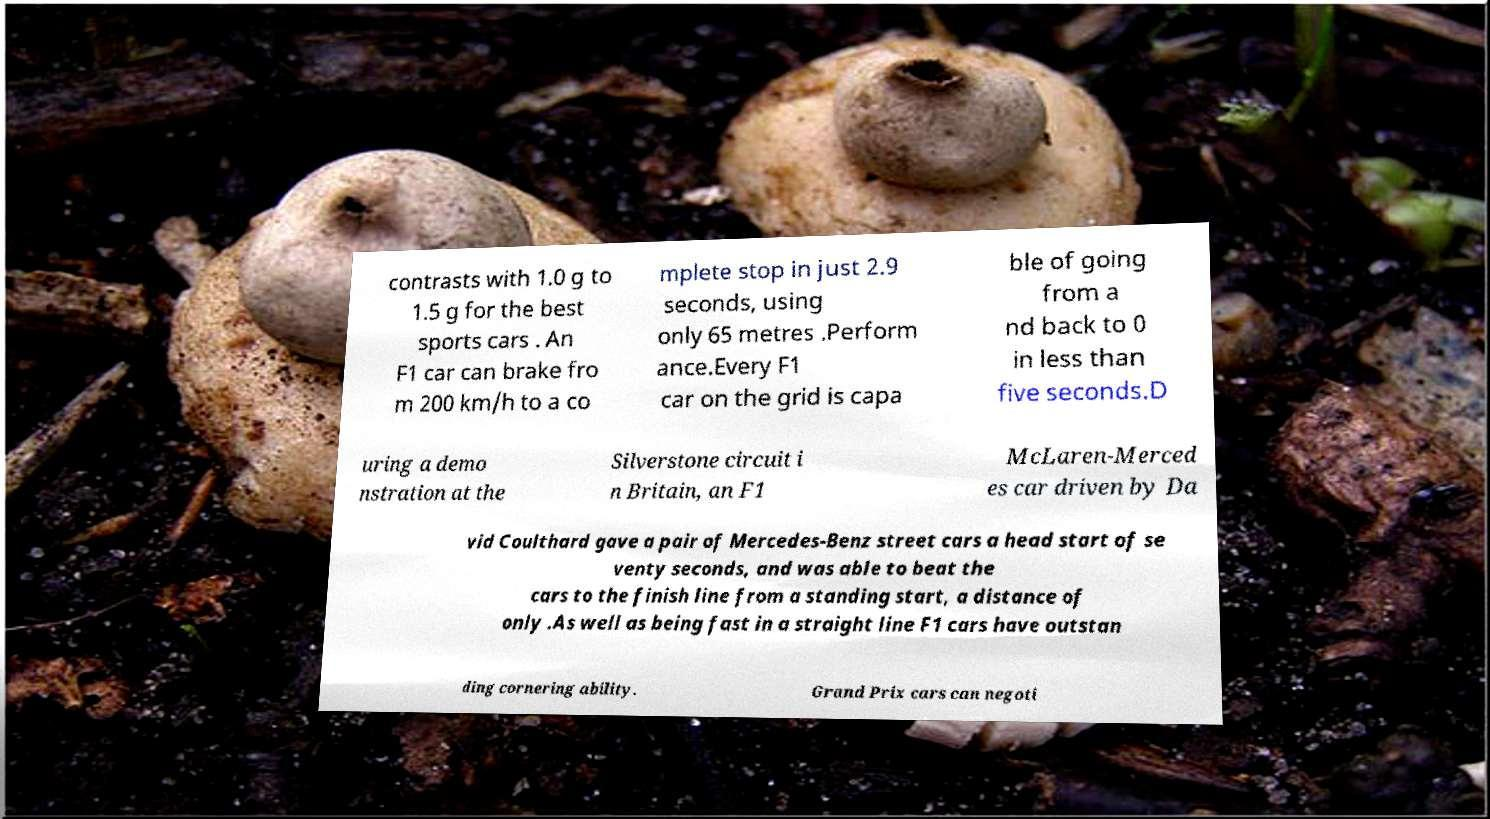What messages or text are displayed in this image? I need them in a readable, typed format. contrasts with 1.0 g to 1.5 g for the best sports cars . An F1 car can brake fro m 200 km/h to a co mplete stop in just 2.9 seconds, using only 65 metres .Perform ance.Every F1 car on the grid is capa ble of going from a nd back to 0 in less than five seconds.D uring a demo nstration at the Silverstone circuit i n Britain, an F1 McLaren-Merced es car driven by Da vid Coulthard gave a pair of Mercedes-Benz street cars a head start of se venty seconds, and was able to beat the cars to the finish line from a standing start, a distance of only .As well as being fast in a straight line F1 cars have outstan ding cornering ability. Grand Prix cars can negoti 